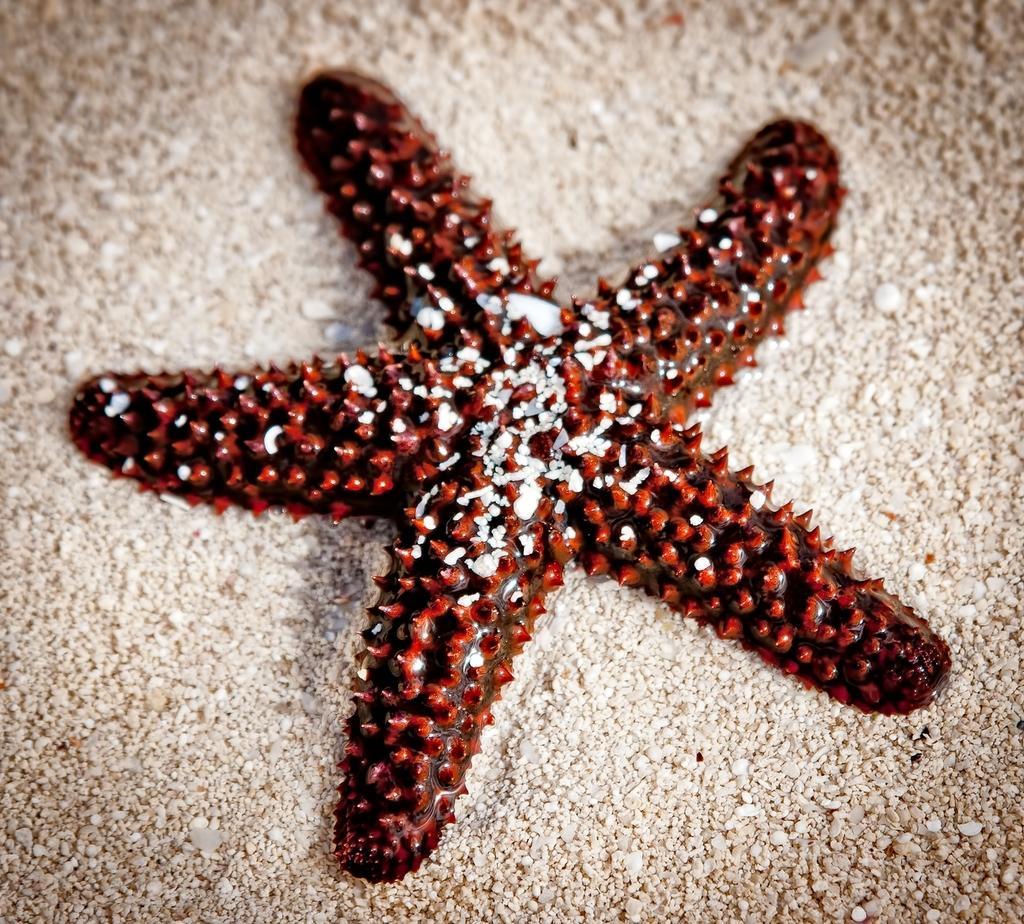Describe this image in one or two sentences. In this image there is starfish in the center which is red in colour. 